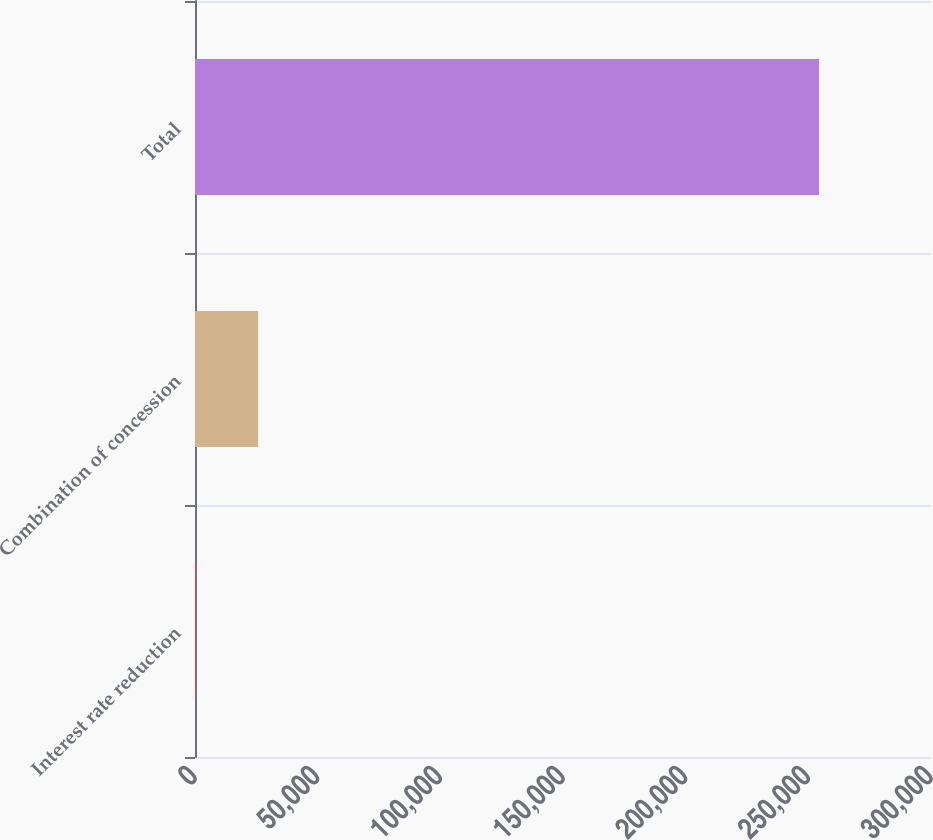<chart> <loc_0><loc_0><loc_500><loc_500><bar_chart><fcel>Interest rate reduction<fcel>Combination of concession<fcel>Total<nl><fcel>335<fcel>25736.7<fcel>254352<nl></chart> 